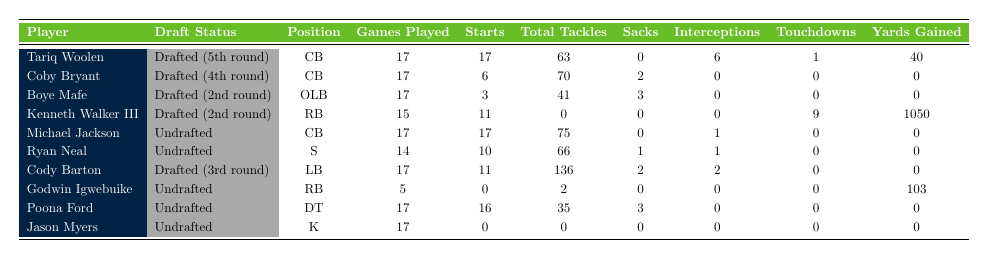What is the total number of games played by all drafted players? The drafted players are Tariq Woolen, Coby Bryant, Boye Mafe, Kenneth Walker III, and Cody Barton. They played 17, 17, 17, 15, and 17 games, respectively. Adding these together: 17 + 17 + 17 + 15 + 17 = 85.
Answer: 85 What is the maximum number of interceptions made by any player? Looking at the interceptions column, Tariq Woolen has 6 interceptions, the highest among all players.
Answer: 6 How many undrafted players started more than 10 games? Among the undrafted players, Michael Jackson started 17 games, Ryan Neal started 10 games, and the others started less. So, only Michael Jackson started more than 10 games.
Answer: 1 What is the average total tackles for all drafted players? The drafted players are Tariq Woolen (63), Coby Bryant (70), Boye Mafe (41), Kenneth Walker III (0), and Cody Barton (136). Their total tackles sum to 63 + 70 + 41 + 0 + 136 = 310. There are 5 drafted players, so the average is 310 / 5 = 62.
Answer: 62 Did Kenneth Walker III score more touchdowns than any undrafted player? Kenneth Walker III scored 9 touchdowns. The undrafted players' touchdowns were Michael Jackson (0), Ryan Neal (0), Godwin Igwebuike (0), Poona Ford (0), and Jason Myers (0). 9 is greater than 0, so yes, he scored more touchdowns.
Answer: Yes What is the difference in total tackles between the drafted player with the most tackles and the undrafted player with the most tackles? The drafted player with the most tackles is Cody Barton with 136, and the undrafted player with the most tackles is Michael Jackson with 75. The difference is 136 - 75 = 61.
Answer: 61 What percentage of games did Kenneth Walker III start? Kenneth Walker III played 15 games and started 11. To find the percentage, we calculate (11 / 15) * 100 = 73.33%.
Answer: 73.33% Which position had the highest total tackles among undrafted players? Among the undrafted players, the total tackles are Michael Jackson (75), Ryan Neal (66), Godwin Igwebuike (2), Poona Ford (35), and Jason Myers (0). Michael Jackson has the highest total tackles with 75.
Answer: CB How many more total yards did Kenneth Walker III gain compared to Michael Jackson? Kenneth Walker III gained 1050 yards, while Michael Jackson gained 0 yards. The difference is 1050 - 0 = 1050.
Answer: 1050 Is there any undrafted player who scored a touchdown? The undrafted players did not score any touchdowns except for Michael Jackson (0), Ryan Neal (0), Godwin Igwebuike (0), Poona Ford (0), and Jason Myers (0). Therefore, no undrafted player scored a touchdown.
Answer: No 